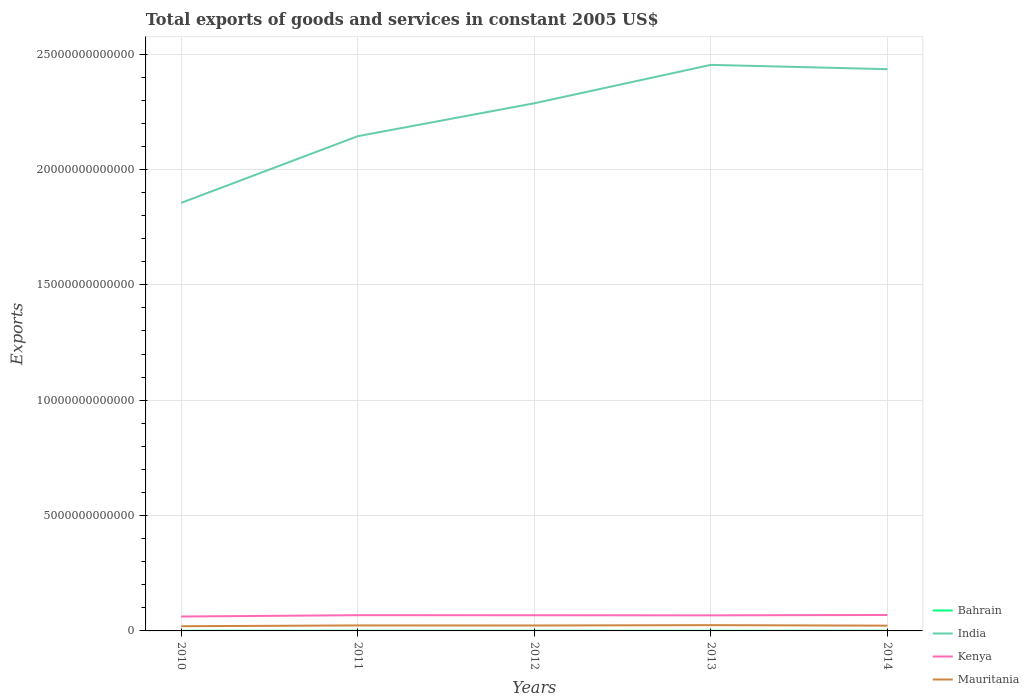How many different coloured lines are there?
Provide a succinct answer. 4. Across all years, what is the maximum total exports of goods and services in Bahrain?
Provide a succinct answer. 6.43e+09. In which year was the total exports of goods and services in Kenya maximum?
Provide a short and direct response. 2010. What is the total total exports of goods and services in Mauritania in the graph?
Provide a succinct answer. -1.57e+1. What is the difference between the highest and the second highest total exports of goods and services in India?
Make the answer very short. 5.98e+12. What is the difference between the highest and the lowest total exports of goods and services in Mauritania?
Offer a terse response. 3. Is the total exports of goods and services in India strictly greater than the total exports of goods and services in Mauritania over the years?
Provide a short and direct response. No. How many years are there in the graph?
Offer a terse response. 5. What is the difference between two consecutive major ticks on the Y-axis?
Your response must be concise. 5.00e+12. Are the values on the major ticks of Y-axis written in scientific E-notation?
Your response must be concise. No. Does the graph contain any zero values?
Provide a short and direct response. No. Where does the legend appear in the graph?
Give a very brief answer. Bottom right. How are the legend labels stacked?
Offer a terse response. Vertical. What is the title of the graph?
Your answer should be compact. Total exports of goods and services in constant 2005 US$. Does "Euro area" appear as one of the legend labels in the graph?
Provide a short and direct response. No. What is the label or title of the Y-axis?
Your answer should be compact. Exports. What is the Exports in Bahrain in 2010?
Give a very brief answer. 6.72e+09. What is the Exports of India in 2010?
Provide a short and direct response. 1.86e+13. What is the Exports of Kenya in 2010?
Provide a short and direct response. 6.24e+11. What is the Exports of Mauritania in 2010?
Give a very brief answer. 2.04e+11. What is the Exports of Bahrain in 2011?
Offer a very short reply. 6.64e+09. What is the Exports in India in 2011?
Offer a terse response. 2.14e+13. What is the Exports in Kenya in 2011?
Provide a succinct answer. 6.82e+11. What is the Exports of Mauritania in 2011?
Make the answer very short. 2.38e+11. What is the Exports in Bahrain in 2012?
Your answer should be compact. 6.43e+09. What is the Exports of India in 2012?
Ensure brevity in your answer.  2.29e+13. What is the Exports in Kenya in 2012?
Provide a succinct answer. 6.79e+11. What is the Exports of Mauritania in 2012?
Ensure brevity in your answer.  2.35e+11. What is the Exports of Bahrain in 2013?
Offer a very short reply. 7.00e+09. What is the Exports in India in 2013?
Your response must be concise. 2.45e+13. What is the Exports in Kenya in 2013?
Your answer should be compact. 6.75e+11. What is the Exports of Mauritania in 2013?
Make the answer very short. 2.50e+11. What is the Exports of Bahrain in 2014?
Offer a very short reply. 7.03e+09. What is the Exports in India in 2014?
Ensure brevity in your answer.  2.43e+13. What is the Exports in Kenya in 2014?
Keep it short and to the point. 6.91e+11. What is the Exports of Mauritania in 2014?
Make the answer very short. 2.28e+11. Across all years, what is the maximum Exports of Bahrain?
Offer a terse response. 7.03e+09. Across all years, what is the maximum Exports of India?
Offer a very short reply. 2.45e+13. Across all years, what is the maximum Exports of Kenya?
Give a very brief answer. 6.91e+11. Across all years, what is the maximum Exports in Mauritania?
Keep it short and to the point. 2.50e+11. Across all years, what is the minimum Exports of Bahrain?
Keep it short and to the point. 6.43e+09. Across all years, what is the minimum Exports of India?
Offer a very short reply. 1.86e+13. Across all years, what is the minimum Exports in Kenya?
Offer a terse response. 6.24e+11. Across all years, what is the minimum Exports of Mauritania?
Provide a succinct answer. 2.04e+11. What is the total Exports of Bahrain in the graph?
Your answer should be compact. 3.38e+1. What is the total Exports of India in the graph?
Offer a terse response. 1.12e+14. What is the total Exports of Kenya in the graph?
Make the answer very short. 3.35e+12. What is the total Exports in Mauritania in the graph?
Offer a very short reply. 1.15e+12. What is the difference between the Exports of Bahrain in 2010 and that in 2011?
Offer a very short reply. 8.00e+07. What is the difference between the Exports of India in 2010 and that in 2011?
Your answer should be compact. -2.89e+12. What is the difference between the Exports of Kenya in 2010 and that in 2011?
Provide a succinct answer. -5.79e+1. What is the difference between the Exports of Mauritania in 2010 and that in 2011?
Provide a succinct answer. -3.44e+1. What is the difference between the Exports of Bahrain in 2010 and that in 2012?
Ensure brevity in your answer.  2.93e+08. What is the difference between the Exports in India in 2010 and that in 2012?
Make the answer very short. -4.32e+12. What is the difference between the Exports in Kenya in 2010 and that in 2012?
Give a very brief answer. -5.52e+1. What is the difference between the Exports of Mauritania in 2010 and that in 2012?
Your answer should be very brief. -3.12e+1. What is the difference between the Exports in Bahrain in 2010 and that in 2013?
Your answer should be compact. -2.79e+08. What is the difference between the Exports in India in 2010 and that in 2013?
Your answer should be compact. -5.98e+12. What is the difference between the Exports in Kenya in 2010 and that in 2013?
Ensure brevity in your answer.  -5.14e+1. What is the difference between the Exports in Mauritania in 2010 and that in 2013?
Your response must be concise. -4.69e+1. What is the difference between the Exports of Bahrain in 2010 and that in 2014?
Provide a succinct answer. -3.09e+08. What is the difference between the Exports of India in 2010 and that in 2014?
Provide a short and direct response. -5.79e+12. What is the difference between the Exports in Kenya in 2010 and that in 2014?
Keep it short and to the point. -6.71e+1. What is the difference between the Exports in Mauritania in 2010 and that in 2014?
Your response must be concise. -2.43e+1. What is the difference between the Exports of Bahrain in 2011 and that in 2012?
Provide a succinct answer. 2.13e+08. What is the difference between the Exports of India in 2011 and that in 2012?
Ensure brevity in your answer.  -1.43e+12. What is the difference between the Exports of Kenya in 2011 and that in 2012?
Keep it short and to the point. 2.67e+09. What is the difference between the Exports of Mauritania in 2011 and that in 2012?
Your answer should be compact. 3.22e+09. What is the difference between the Exports of Bahrain in 2011 and that in 2013?
Your response must be concise. -3.59e+08. What is the difference between the Exports in India in 2011 and that in 2013?
Make the answer very short. -3.09e+12. What is the difference between the Exports of Kenya in 2011 and that in 2013?
Give a very brief answer. 6.44e+09. What is the difference between the Exports in Mauritania in 2011 and that in 2013?
Give a very brief answer. -1.25e+1. What is the difference between the Exports of Bahrain in 2011 and that in 2014?
Your response must be concise. -3.89e+08. What is the difference between the Exports in India in 2011 and that in 2014?
Provide a succinct answer. -2.90e+12. What is the difference between the Exports in Kenya in 2011 and that in 2014?
Your response must be concise. -9.18e+09. What is the difference between the Exports in Mauritania in 2011 and that in 2014?
Your answer should be very brief. 1.01e+1. What is the difference between the Exports in Bahrain in 2012 and that in 2013?
Keep it short and to the point. -5.72e+08. What is the difference between the Exports in India in 2012 and that in 2013?
Ensure brevity in your answer.  -1.66e+12. What is the difference between the Exports of Kenya in 2012 and that in 2013?
Your answer should be compact. 3.77e+09. What is the difference between the Exports in Mauritania in 2012 and that in 2013?
Make the answer very short. -1.57e+1. What is the difference between the Exports of Bahrain in 2012 and that in 2014?
Your answer should be very brief. -6.02e+08. What is the difference between the Exports in India in 2012 and that in 2014?
Provide a short and direct response. -1.48e+12. What is the difference between the Exports of Kenya in 2012 and that in 2014?
Ensure brevity in your answer.  -1.18e+1. What is the difference between the Exports in Mauritania in 2012 and that in 2014?
Provide a short and direct response. 6.89e+09. What is the difference between the Exports in Bahrain in 2013 and that in 2014?
Provide a succinct answer. -3.00e+07. What is the difference between the Exports in India in 2013 and that in 2014?
Offer a very short reply. 1.87e+11. What is the difference between the Exports of Kenya in 2013 and that in 2014?
Your answer should be compact. -1.56e+1. What is the difference between the Exports of Mauritania in 2013 and that in 2014?
Offer a very short reply. 2.26e+1. What is the difference between the Exports of Bahrain in 2010 and the Exports of India in 2011?
Provide a short and direct response. -2.14e+13. What is the difference between the Exports in Bahrain in 2010 and the Exports in Kenya in 2011?
Provide a short and direct response. -6.75e+11. What is the difference between the Exports of Bahrain in 2010 and the Exports of Mauritania in 2011?
Ensure brevity in your answer.  -2.31e+11. What is the difference between the Exports in India in 2010 and the Exports in Kenya in 2011?
Provide a succinct answer. 1.79e+13. What is the difference between the Exports in India in 2010 and the Exports in Mauritania in 2011?
Offer a terse response. 1.83e+13. What is the difference between the Exports in Kenya in 2010 and the Exports in Mauritania in 2011?
Give a very brief answer. 3.86e+11. What is the difference between the Exports in Bahrain in 2010 and the Exports in India in 2012?
Make the answer very short. -2.29e+13. What is the difference between the Exports of Bahrain in 2010 and the Exports of Kenya in 2012?
Provide a short and direct response. -6.72e+11. What is the difference between the Exports in Bahrain in 2010 and the Exports in Mauritania in 2012?
Ensure brevity in your answer.  -2.28e+11. What is the difference between the Exports of India in 2010 and the Exports of Kenya in 2012?
Give a very brief answer. 1.79e+13. What is the difference between the Exports of India in 2010 and the Exports of Mauritania in 2012?
Provide a succinct answer. 1.83e+13. What is the difference between the Exports of Kenya in 2010 and the Exports of Mauritania in 2012?
Make the answer very short. 3.89e+11. What is the difference between the Exports of Bahrain in 2010 and the Exports of India in 2013?
Keep it short and to the point. -2.45e+13. What is the difference between the Exports in Bahrain in 2010 and the Exports in Kenya in 2013?
Offer a terse response. -6.69e+11. What is the difference between the Exports of Bahrain in 2010 and the Exports of Mauritania in 2013?
Ensure brevity in your answer.  -2.44e+11. What is the difference between the Exports in India in 2010 and the Exports in Kenya in 2013?
Your response must be concise. 1.79e+13. What is the difference between the Exports of India in 2010 and the Exports of Mauritania in 2013?
Your answer should be compact. 1.83e+13. What is the difference between the Exports of Kenya in 2010 and the Exports of Mauritania in 2013?
Your response must be concise. 3.73e+11. What is the difference between the Exports in Bahrain in 2010 and the Exports in India in 2014?
Give a very brief answer. -2.43e+13. What is the difference between the Exports of Bahrain in 2010 and the Exports of Kenya in 2014?
Provide a short and direct response. -6.84e+11. What is the difference between the Exports in Bahrain in 2010 and the Exports in Mauritania in 2014?
Your answer should be very brief. -2.21e+11. What is the difference between the Exports of India in 2010 and the Exports of Kenya in 2014?
Provide a short and direct response. 1.79e+13. What is the difference between the Exports of India in 2010 and the Exports of Mauritania in 2014?
Give a very brief answer. 1.83e+13. What is the difference between the Exports in Kenya in 2010 and the Exports in Mauritania in 2014?
Make the answer very short. 3.96e+11. What is the difference between the Exports of Bahrain in 2011 and the Exports of India in 2012?
Provide a short and direct response. -2.29e+13. What is the difference between the Exports of Bahrain in 2011 and the Exports of Kenya in 2012?
Offer a terse response. -6.72e+11. What is the difference between the Exports of Bahrain in 2011 and the Exports of Mauritania in 2012?
Your answer should be very brief. -2.28e+11. What is the difference between the Exports of India in 2011 and the Exports of Kenya in 2012?
Offer a terse response. 2.08e+13. What is the difference between the Exports in India in 2011 and the Exports in Mauritania in 2012?
Your response must be concise. 2.12e+13. What is the difference between the Exports of Kenya in 2011 and the Exports of Mauritania in 2012?
Your response must be concise. 4.47e+11. What is the difference between the Exports in Bahrain in 2011 and the Exports in India in 2013?
Your answer should be compact. -2.45e+13. What is the difference between the Exports of Bahrain in 2011 and the Exports of Kenya in 2013?
Make the answer very short. -6.69e+11. What is the difference between the Exports of Bahrain in 2011 and the Exports of Mauritania in 2013?
Provide a short and direct response. -2.44e+11. What is the difference between the Exports of India in 2011 and the Exports of Kenya in 2013?
Your response must be concise. 2.08e+13. What is the difference between the Exports in India in 2011 and the Exports in Mauritania in 2013?
Your answer should be very brief. 2.12e+13. What is the difference between the Exports of Kenya in 2011 and the Exports of Mauritania in 2013?
Provide a succinct answer. 4.31e+11. What is the difference between the Exports in Bahrain in 2011 and the Exports in India in 2014?
Make the answer very short. -2.43e+13. What is the difference between the Exports in Bahrain in 2011 and the Exports in Kenya in 2014?
Keep it short and to the point. -6.84e+11. What is the difference between the Exports in Bahrain in 2011 and the Exports in Mauritania in 2014?
Your answer should be very brief. -2.21e+11. What is the difference between the Exports in India in 2011 and the Exports in Kenya in 2014?
Offer a very short reply. 2.07e+13. What is the difference between the Exports of India in 2011 and the Exports of Mauritania in 2014?
Your response must be concise. 2.12e+13. What is the difference between the Exports of Kenya in 2011 and the Exports of Mauritania in 2014?
Your response must be concise. 4.54e+11. What is the difference between the Exports of Bahrain in 2012 and the Exports of India in 2013?
Provide a short and direct response. -2.45e+13. What is the difference between the Exports in Bahrain in 2012 and the Exports in Kenya in 2013?
Make the answer very short. -6.69e+11. What is the difference between the Exports in Bahrain in 2012 and the Exports in Mauritania in 2013?
Provide a succinct answer. -2.44e+11. What is the difference between the Exports in India in 2012 and the Exports in Kenya in 2013?
Make the answer very short. 2.22e+13. What is the difference between the Exports in India in 2012 and the Exports in Mauritania in 2013?
Offer a very short reply. 2.26e+13. What is the difference between the Exports of Kenya in 2012 and the Exports of Mauritania in 2013?
Keep it short and to the point. 4.29e+11. What is the difference between the Exports of Bahrain in 2012 and the Exports of India in 2014?
Offer a very short reply. -2.43e+13. What is the difference between the Exports of Bahrain in 2012 and the Exports of Kenya in 2014?
Ensure brevity in your answer.  -6.84e+11. What is the difference between the Exports in Bahrain in 2012 and the Exports in Mauritania in 2014?
Keep it short and to the point. -2.21e+11. What is the difference between the Exports in India in 2012 and the Exports in Kenya in 2014?
Provide a short and direct response. 2.22e+13. What is the difference between the Exports of India in 2012 and the Exports of Mauritania in 2014?
Your response must be concise. 2.26e+13. What is the difference between the Exports in Kenya in 2012 and the Exports in Mauritania in 2014?
Give a very brief answer. 4.51e+11. What is the difference between the Exports of Bahrain in 2013 and the Exports of India in 2014?
Your answer should be compact. -2.43e+13. What is the difference between the Exports in Bahrain in 2013 and the Exports in Kenya in 2014?
Provide a short and direct response. -6.84e+11. What is the difference between the Exports in Bahrain in 2013 and the Exports in Mauritania in 2014?
Ensure brevity in your answer.  -2.21e+11. What is the difference between the Exports of India in 2013 and the Exports of Kenya in 2014?
Offer a terse response. 2.38e+13. What is the difference between the Exports of India in 2013 and the Exports of Mauritania in 2014?
Make the answer very short. 2.43e+13. What is the difference between the Exports of Kenya in 2013 and the Exports of Mauritania in 2014?
Give a very brief answer. 4.47e+11. What is the average Exports in Bahrain per year?
Give a very brief answer. 6.77e+09. What is the average Exports of India per year?
Offer a terse response. 2.23e+13. What is the average Exports in Kenya per year?
Your answer should be very brief. 6.70e+11. What is the average Exports of Mauritania per year?
Offer a terse response. 2.31e+11. In the year 2010, what is the difference between the Exports of Bahrain and Exports of India?
Your response must be concise. -1.85e+13. In the year 2010, what is the difference between the Exports of Bahrain and Exports of Kenya?
Provide a succinct answer. -6.17e+11. In the year 2010, what is the difference between the Exports in Bahrain and Exports in Mauritania?
Your answer should be very brief. -1.97e+11. In the year 2010, what is the difference between the Exports in India and Exports in Kenya?
Your answer should be compact. 1.79e+13. In the year 2010, what is the difference between the Exports of India and Exports of Mauritania?
Keep it short and to the point. 1.83e+13. In the year 2010, what is the difference between the Exports of Kenya and Exports of Mauritania?
Make the answer very short. 4.20e+11. In the year 2011, what is the difference between the Exports in Bahrain and Exports in India?
Your answer should be very brief. -2.14e+13. In the year 2011, what is the difference between the Exports of Bahrain and Exports of Kenya?
Ensure brevity in your answer.  -6.75e+11. In the year 2011, what is the difference between the Exports of Bahrain and Exports of Mauritania?
Provide a short and direct response. -2.31e+11. In the year 2011, what is the difference between the Exports of India and Exports of Kenya?
Provide a short and direct response. 2.08e+13. In the year 2011, what is the difference between the Exports of India and Exports of Mauritania?
Give a very brief answer. 2.12e+13. In the year 2011, what is the difference between the Exports in Kenya and Exports in Mauritania?
Your response must be concise. 4.44e+11. In the year 2012, what is the difference between the Exports in Bahrain and Exports in India?
Make the answer very short. -2.29e+13. In the year 2012, what is the difference between the Exports in Bahrain and Exports in Kenya?
Provide a succinct answer. -6.73e+11. In the year 2012, what is the difference between the Exports of Bahrain and Exports of Mauritania?
Your response must be concise. -2.28e+11. In the year 2012, what is the difference between the Exports of India and Exports of Kenya?
Offer a very short reply. 2.22e+13. In the year 2012, what is the difference between the Exports of India and Exports of Mauritania?
Ensure brevity in your answer.  2.26e+13. In the year 2012, what is the difference between the Exports in Kenya and Exports in Mauritania?
Your answer should be very brief. 4.44e+11. In the year 2013, what is the difference between the Exports in Bahrain and Exports in India?
Your answer should be compact. -2.45e+13. In the year 2013, what is the difference between the Exports of Bahrain and Exports of Kenya?
Keep it short and to the point. -6.68e+11. In the year 2013, what is the difference between the Exports in Bahrain and Exports in Mauritania?
Offer a very short reply. -2.43e+11. In the year 2013, what is the difference between the Exports of India and Exports of Kenya?
Provide a succinct answer. 2.39e+13. In the year 2013, what is the difference between the Exports of India and Exports of Mauritania?
Keep it short and to the point. 2.43e+13. In the year 2013, what is the difference between the Exports in Kenya and Exports in Mauritania?
Provide a succinct answer. 4.25e+11. In the year 2014, what is the difference between the Exports in Bahrain and Exports in India?
Offer a terse response. -2.43e+13. In the year 2014, what is the difference between the Exports in Bahrain and Exports in Kenya?
Ensure brevity in your answer.  -6.84e+11. In the year 2014, what is the difference between the Exports of Bahrain and Exports of Mauritania?
Provide a short and direct response. -2.21e+11. In the year 2014, what is the difference between the Exports of India and Exports of Kenya?
Your answer should be very brief. 2.37e+13. In the year 2014, what is the difference between the Exports in India and Exports in Mauritania?
Make the answer very short. 2.41e+13. In the year 2014, what is the difference between the Exports of Kenya and Exports of Mauritania?
Provide a short and direct response. 4.63e+11. What is the ratio of the Exports in India in 2010 to that in 2011?
Offer a very short reply. 0.87. What is the ratio of the Exports of Kenya in 2010 to that in 2011?
Your answer should be very brief. 0.92. What is the ratio of the Exports of Mauritania in 2010 to that in 2011?
Keep it short and to the point. 0.86. What is the ratio of the Exports in Bahrain in 2010 to that in 2012?
Ensure brevity in your answer.  1.05. What is the ratio of the Exports of India in 2010 to that in 2012?
Your response must be concise. 0.81. What is the ratio of the Exports of Kenya in 2010 to that in 2012?
Give a very brief answer. 0.92. What is the ratio of the Exports of Mauritania in 2010 to that in 2012?
Give a very brief answer. 0.87. What is the ratio of the Exports of Bahrain in 2010 to that in 2013?
Keep it short and to the point. 0.96. What is the ratio of the Exports in India in 2010 to that in 2013?
Ensure brevity in your answer.  0.76. What is the ratio of the Exports of Kenya in 2010 to that in 2013?
Provide a succinct answer. 0.92. What is the ratio of the Exports in Mauritania in 2010 to that in 2013?
Offer a terse response. 0.81. What is the ratio of the Exports of Bahrain in 2010 to that in 2014?
Give a very brief answer. 0.96. What is the ratio of the Exports of India in 2010 to that in 2014?
Provide a short and direct response. 0.76. What is the ratio of the Exports in Kenya in 2010 to that in 2014?
Provide a short and direct response. 0.9. What is the ratio of the Exports in Mauritania in 2010 to that in 2014?
Make the answer very short. 0.89. What is the ratio of the Exports of Bahrain in 2011 to that in 2012?
Your response must be concise. 1.03. What is the ratio of the Exports of India in 2011 to that in 2012?
Ensure brevity in your answer.  0.94. What is the ratio of the Exports in Kenya in 2011 to that in 2012?
Offer a very short reply. 1. What is the ratio of the Exports of Mauritania in 2011 to that in 2012?
Ensure brevity in your answer.  1.01. What is the ratio of the Exports of Bahrain in 2011 to that in 2013?
Make the answer very short. 0.95. What is the ratio of the Exports in India in 2011 to that in 2013?
Give a very brief answer. 0.87. What is the ratio of the Exports of Kenya in 2011 to that in 2013?
Make the answer very short. 1.01. What is the ratio of the Exports of Mauritania in 2011 to that in 2013?
Provide a short and direct response. 0.95. What is the ratio of the Exports of Bahrain in 2011 to that in 2014?
Give a very brief answer. 0.94. What is the ratio of the Exports of India in 2011 to that in 2014?
Offer a terse response. 0.88. What is the ratio of the Exports in Kenya in 2011 to that in 2014?
Your answer should be compact. 0.99. What is the ratio of the Exports in Mauritania in 2011 to that in 2014?
Your answer should be compact. 1.04. What is the ratio of the Exports of Bahrain in 2012 to that in 2013?
Your answer should be very brief. 0.92. What is the ratio of the Exports of India in 2012 to that in 2013?
Keep it short and to the point. 0.93. What is the ratio of the Exports of Kenya in 2012 to that in 2013?
Your answer should be compact. 1.01. What is the ratio of the Exports of Mauritania in 2012 to that in 2013?
Provide a short and direct response. 0.94. What is the ratio of the Exports of Bahrain in 2012 to that in 2014?
Offer a terse response. 0.91. What is the ratio of the Exports in India in 2012 to that in 2014?
Your answer should be very brief. 0.94. What is the ratio of the Exports in Kenya in 2012 to that in 2014?
Provide a succinct answer. 0.98. What is the ratio of the Exports of Mauritania in 2012 to that in 2014?
Provide a succinct answer. 1.03. What is the ratio of the Exports of Bahrain in 2013 to that in 2014?
Make the answer very short. 1. What is the ratio of the Exports of India in 2013 to that in 2014?
Your answer should be very brief. 1.01. What is the ratio of the Exports in Kenya in 2013 to that in 2014?
Your answer should be very brief. 0.98. What is the ratio of the Exports in Mauritania in 2013 to that in 2014?
Keep it short and to the point. 1.1. What is the difference between the highest and the second highest Exports of Bahrain?
Make the answer very short. 3.00e+07. What is the difference between the highest and the second highest Exports in India?
Ensure brevity in your answer.  1.87e+11. What is the difference between the highest and the second highest Exports of Kenya?
Provide a succinct answer. 9.18e+09. What is the difference between the highest and the second highest Exports of Mauritania?
Make the answer very short. 1.25e+1. What is the difference between the highest and the lowest Exports in Bahrain?
Ensure brevity in your answer.  6.02e+08. What is the difference between the highest and the lowest Exports in India?
Keep it short and to the point. 5.98e+12. What is the difference between the highest and the lowest Exports in Kenya?
Make the answer very short. 6.71e+1. What is the difference between the highest and the lowest Exports in Mauritania?
Your answer should be compact. 4.69e+1. 